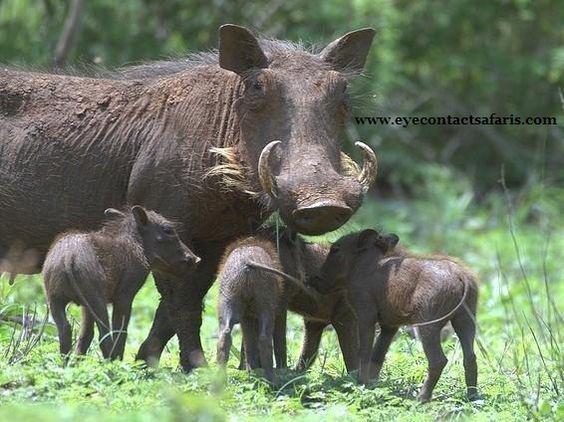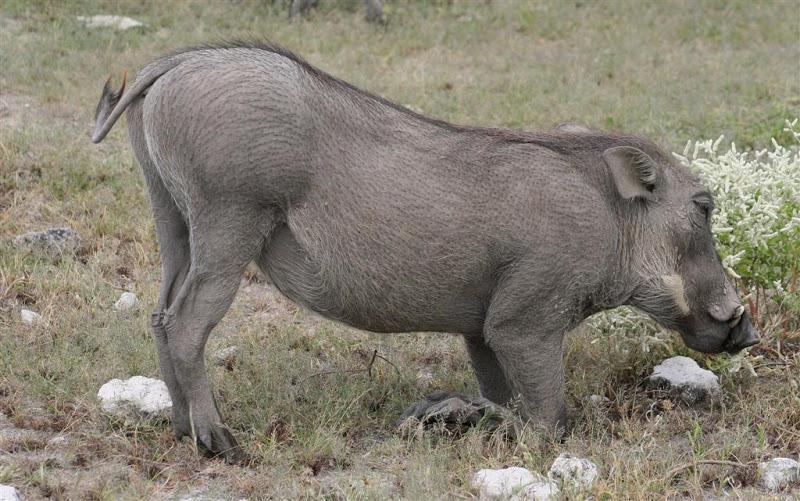The first image is the image on the left, the second image is the image on the right. Analyze the images presented: Is the assertion "Two of the animals in the image on the left are butting heads." valid? Answer yes or no. No. The first image is the image on the left, the second image is the image on the right. Assess this claim about the two images: "An image shows two warthogs face-to-face in the foreground, and no warthogs face-to-face in the background.". Correct or not? Answer yes or no. No. 